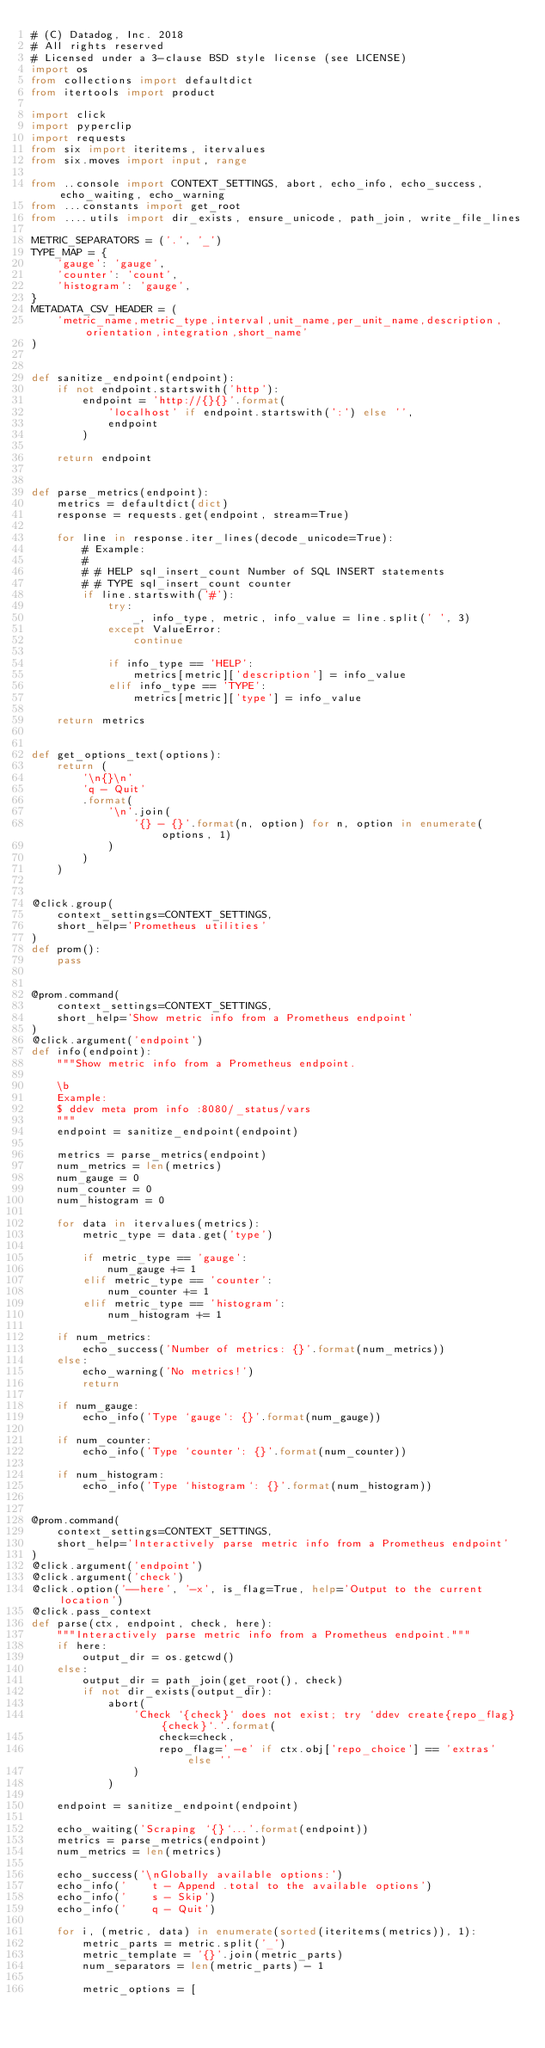Convert code to text. <code><loc_0><loc_0><loc_500><loc_500><_Python_># (C) Datadog, Inc. 2018
# All rights reserved
# Licensed under a 3-clause BSD style license (see LICENSE)
import os
from collections import defaultdict
from itertools import product

import click
import pyperclip
import requests
from six import iteritems, itervalues
from six.moves import input, range

from ..console import CONTEXT_SETTINGS, abort, echo_info, echo_success, echo_waiting, echo_warning
from ...constants import get_root
from ....utils import dir_exists, ensure_unicode, path_join, write_file_lines

METRIC_SEPARATORS = ('.', '_')
TYPE_MAP = {
    'gauge': 'gauge',
    'counter': 'count',
    'histogram': 'gauge',
}
METADATA_CSV_HEADER = (
    'metric_name,metric_type,interval,unit_name,per_unit_name,description,orientation,integration,short_name'
)


def sanitize_endpoint(endpoint):
    if not endpoint.startswith('http'):
        endpoint = 'http://{}{}'.format(
            'localhost' if endpoint.startswith(':') else '',
            endpoint
        )

    return endpoint


def parse_metrics(endpoint):
    metrics = defaultdict(dict)
    response = requests.get(endpoint, stream=True)

    for line in response.iter_lines(decode_unicode=True):
        # Example:
        #
        # # HELP sql_insert_count Number of SQL INSERT statements
        # # TYPE sql_insert_count counter
        if line.startswith('#'):
            try:
                _, info_type, metric, info_value = line.split(' ', 3)
            except ValueError:
                continue

            if info_type == 'HELP':
                metrics[metric]['description'] = info_value
            elif info_type == 'TYPE':
                metrics[metric]['type'] = info_value

    return metrics


def get_options_text(options):
    return (
        '\n{}\n'
        'q - Quit'
        .format(
            '\n'.join(
                '{} - {}'.format(n, option) for n, option in enumerate(options, 1)
            )
        )
    )


@click.group(
    context_settings=CONTEXT_SETTINGS,
    short_help='Prometheus utilities'
)
def prom():
    pass


@prom.command(
    context_settings=CONTEXT_SETTINGS,
    short_help='Show metric info from a Prometheus endpoint'
)
@click.argument('endpoint')
def info(endpoint):
    """Show metric info from a Prometheus endpoint.

    \b
    Example:
    $ ddev meta prom info :8080/_status/vars
    """
    endpoint = sanitize_endpoint(endpoint)

    metrics = parse_metrics(endpoint)
    num_metrics = len(metrics)
    num_gauge = 0
    num_counter = 0
    num_histogram = 0

    for data in itervalues(metrics):
        metric_type = data.get('type')

        if metric_type == 'gauge':
            num_gauge += 1
        elif metric_type == 'counter':
            num_counter += 1
        elif metric_type == 'histogram':
            num_histogram += 1

    if num_metrics:
        echo_success('Number of metrics: {}'.format(num_metrics))
    else:
        echo_warning('No metrics!')
        return

    if num_gauge:
        echo_info('Type `gauge`: {}'.format(num_gauge))

    if num_counter:
        echo_info('Type `counter`: {}'.format(num_counter))

    if num_histogram:
        echo_info('Type `histogram`: {}'.format(num_histogram))


@prom.command(
    context_settings=CONTEXT_SETTINGS,
    short_help='Interactively parse metric info from a Prometheus endpoint'
)
@click.argument('endpoint')
@click.argument('check')
@click.option('--here', '-x', is_flag=True, help='Output to the current location')
@click.pass_context
def parse(ctx, endpoint, check, here):
    """Interactively parse metric info from a Prometheus endpoint."""
    if here:
        output_dir = os.getcwd()
    else:
        output_dir = path_join(get_root(), check)
        if not dir_exists(output_dir):
            abort(
                'Check `{check}` does not exist; try `ddev create{repo_flag} {check}`.'.format(
                    check=check,
                    repo_flag=' -e' if ctx.obj['repo_choice'] == 'extras' else ''
                )
            )

    endpoint = sanitize_endpoint(endpoint)

    echo_waiting('Scraping `{}`...'.format(endpoint))
    metrics = parse_metrics(endpoint)
    num_metrics = len(metrics)

    echo_success('\nGlobally available options:')
    echo_info('    t - Append .total to the available options')
    echo_info('    s - Skip')
    echo_info('    q - Quit')

    for i, (metric, data) in enumerate(sorted(iteritems(metrics)), 1):
        metric_parts = metric.split('_')
        metric_template = '{}'.join(metric_parts)
        num_separators = len(metric_parts) - 1

        metric_options = [</code> 